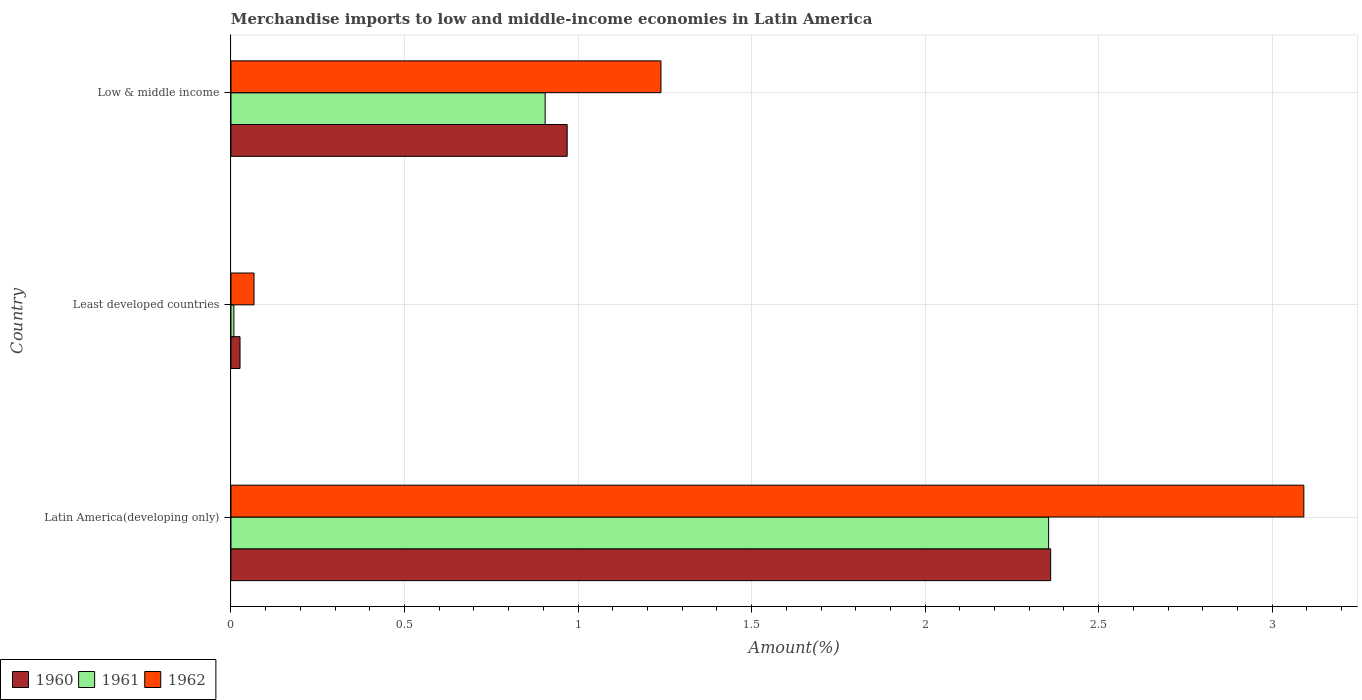How many different coloured bars are there?
Keep it short and to the point. 3. Are the number of bars on each tick of the Y-axis equal?
Ensure brevity in your answer.  Yes. How many bars are there on the 3rd tick from the top?
Your response must be concise. 3. How many bars are there on the 3rd tick from the bottom?
Make the answer very short. 3. What is the label of the 3rd group of bars from the top?
Offer a very short reply. Latin America(developing only). In how many cases, is the number of bars for a given country not equal to the number of legend labels?
Your response must be concise. 0. What is the percentage of amount earned from merchandise imports in 1960 in Low & middle income?
Offer a terse response. 0.97. Across all countries, what is the maximum percentage of amount earned from merchandise imports in 1960?
Ensure brevity in your answer.  2.36. Across all countries, what is the minimum percentage of amount earned from merchandise imports in 1961?
Your response must be concise. 0.01. In which country was the percentage of amount earned from merchandise imports in 1962 maximum?
Your answer should be very brief. Latin America(developing only). In which country was the percentage of amount earned from merchandise imports in 1962 minimum?
Your answer should be compact. Least developed countries. What is the total percentage of amount earned from merchandise imports in 1962 in the graph?
Provide a succinct answer. 4.4. What is the difference between the percentage of amount earned from merchandise imports in 1961 in Latin America(developing only) and that in Low & middle income?
Provide a short and direct response. 1.45. What is the difference between the percentage of amount earned from merchandise imports in 1960 in Latin America(developing only) and the percentage of amount earned from merchandise imports in 1961 in Least developed countries?
Ensure brevity in your answer.  2.35. What is the average percentage of amount earned from merchandise imports in 1960 per country?
Your answer should be compact. 1.12. What is the difference between the percentage of amount earned from merchandise imports in 1960 and percentage of amount earned from merchandise imports in 1961 in Least developed countries?
Provide a short and direct response. 0.02. What is the ratio of the percentage of amount earned from merchandise imports in 1962 in Latin America(developing only) to that in Least developed countries?
Your answer should be very brief. 46.58. What is the difference between the highest and the second highest percentage of amount earned from merchandise imports in 1961?
Your answer should be compact. 1.45. What is the difference between the highest and the lowest percentage of amount earned from merchandise imports in 1960?
Keep it short and to the point. 2.34. Is the sum of the percentage of amount earned from merchandise imports in 1961 in Latin America(developing only) and Low & middle income greater than the maximum percentage of amount earned from merchandise imports in 1960 across all countries?
Your response must be concise. Yes. Is it the case that in every country, the sum of the percentage of amount earned from merchandise imports in 1961 and percentage of amount earned from merchandise imports in 1960 is greater than the percentage of amount earned from merchandise imports in 1962?
Provide a short and direct response. No. How many bars are there?
Offer a terse response. 9. Are all the bars in the graph horizontal?
Your answer should be very brief. Yes. Are the values on the major ticks of X-axis written in scientific E-notation?
Provide a short and direct response. No. Does the graph contain any zero values?
Offer a terse response. No. Where does the legend appear in the graph?
Your response must be concise. Bottom left. What is the title of the graph?
Ensure brevity in your answer.  Merchandise imports to low and middle-income economies in Latin America. What is the label or title of the X-axis?
Make the answer very short. Amount(%). What is the Amount(%) in 1960 in Latin America(developing only)?
Offer a very short reply. 2.36. What is the Amount(%) in 1961 in Latin America(developing only)?
Offer a terse response. 2.36. What is the Amount(%) of 1962 in Latin America(developing only)?
Your response must be concise. 3.09. What is the Amount(%) in 1960 in Least developed countries?
Offer a terse response. 0.03. What is the Amount(%) of 1961 in Least developed countries?
Offer a terse response. 0.01. What is the Amount(%) in 1962 in Least developed countries?
Make the answer very short. 0.07. What is the Amount(%) of 1960 in Low & middle income?
Keep it short and to the point. 0.97. What is the Amount(%) of 1961 in Low & middle income?
Offer a very short reply. 0.91. What is the Amount(%) of 1962 in Low & middle income?
Make the answer very short. 1.24. Across all countries, what is the maximum Amount(%) in 1960?
Provide a succinct answer. 2.36. Across all countries, what is the maximum Amount(%) in 1961?
Offer a very short reply. 2.36. Across all countries, what is the maximum Amount(%) of 1962?
Offer a very short reply. 3.09. Across all countries, what is the minimum Amount(%) in 1960?
Your response must be concise. 0.03. Across all countries, what is the minimum Amount(%) of 1961?
Offer a very short reply. 0.01. Across all countries, what is the minimum Amount(%) of 1962?
Your answer should be compact. 0.07. What is the total Amount(%) in 1960 in the graph?
Keep it short and to the point. 3.36. What is the total Amount(%) in 1961 in the graph?
Your answer should be compact. 3.27. What is the total Amount(%) of 1962 in the graph?
Make the answer very short. 4.4. What is the difference between the Amount(%) in 1960 in Latin America(developing only) and that in Least developed countries?
Offer a very short reply. 2.34. What is the difference between the Amount(%) of 1961 in Latin America(developing only) and that in Least developed countries?
Your response must be concise. 2.35. What is the difference between the Amount(%) of 1962 in Latin America(developing only) and that in Least developed countries?
Ensure brevity in your answer.  3.02. What is the difference between the Amount(%) in 1960 in Latin America(developing only) and that in Low & middle income?
Offer a terse response. 1.39. What is the difference between the Amount(%) of 1961 in Latin America(developing only) and that in Low & middle income?
Your response must be concise. 1.45. What is the difference between the Amount(%) of 1962 in Latin America(developing only) and that in Low & middle income?
Ensure brevity in your answer.  1.85. What is the difference between the Amount(%) in 1960 in Least developed countries and that in Low & middle income?
Give a very brief answer. -0.94. What is the difference between the Amount(%) in 1961 in Least developed countries and that in Low & middle income?
Make the answer very short. -0.9. What is the difference between the Amount(%) in 1962 in Least developed countries and that in Low & middle income?
Offer a terse response. -1.17. What is the difference between the Amount(%) in 1960 in Latin America(developing only) and the Amount(%) in 1961 in Least developed countries?
Make the answer very short. 2.35. What is the difference between the Amount(%) of 1960 in Latin America(developing only) and the Amount(%) of 1962 in Least developed countries?
Your answer should be very brief. 2.3. What is the difference between the Amount(%) of 1961 in Latin America(developing only) and the Amount(%) of 1962 in Least developed countries?
Your answer should be very brief. 2.29. What is the difference between the Amount(%) of 1960 in Latin America(developing only) and the Amount(%) of 1961 in Low & middle income?
Keep it short and to the point. 1.46. What is the difference between the Amount(%) of 1960 in Latin America(developing only) and the Amount(%) of 1962 in Low & middle income?
Offer a very short reply. 1.12. What is the difference between the Amount(%) of 1961 in Latin America(developing only) and the Amount(%) of 1962 in Low & middle income?
Provide a short and direct response. 1.12. What is the difference between the Amount(%) of 1960 in Least developed countries and the Amount(%) of 1961 in Low & middle income?
Your response must be concise. -0.88. What is the difference between the Amount(%) in 1960 in Least developed countries and the Amount(%) in 1962 in Low & middle income?
Your answer should be compact. -1.21. What is the difference between the Amount(%) in 1961 in Least developed countries and the Amount(%) in 1962 in Low & middle income?
Provide a short and direct response. -1.23. What is the average Amount(%) in 1960 per country?
Provide a succinct answer. 1.12. What is the average Amount(%) of 1961 per country?
Your response must be concise. 1.09. What is the average Amount(%) in 1962 per country?
Make the answer very short. 1.47. What is the difference between the Amount(%) of 1960 and Amount(%) of 1961 in Latin America(developing only)?
Offer a very short reply. 0.01. What is the difference between the Amount(%) of 1960 and Amount(%) of 1962 in Latin America(developing only)?
Give a very brief answer. -0.73. What is the difference between the Amount(%) in 1961 and Amount(%) in 1962 in Latin America(developing only)?
Your response must be concise. -0.74. What is the difference between the Amount(%) in 1960 and Amount(%) in 1961 in Least developed countries?
Your answer should be very brief. 0.02. What is the difference between the Amount(%) of 1960 and Amount(%) of 1962 in Least developed countries?
Your answer should be compact. -0.04. What is the difference between the Amount(%) of 1961 and Amount(%) of 1962 in Least developed countries?
Your answer should be compact. -0.06. What is the difference between the Amount(%) of 1960 and Amount(%) of 1961 in Low & middle income?
Your answer should be very brief. 0.06. What is the difference between the Amount(%) in 1960 and Amount(%) in 1962 in Low & middle income?
Provide a succinct answer. -0.27. What is the difference between the Amount(%) in 1961 and Amount(%) in 1962 in Low & middle income?
Keep it short and to the point. -0.33. What is the ratio of the Amount(%) of 1960 in Latin America(developing only) to that in Least developed countries?
Your answer should be compact. 90.55. What is the ratio of the Amount(%) of 1961 in Latin America(developing only) to that in Least developed countries?
Offer a terse response. 282.62. What is the ratio of the Amount(%) in 1962 in Latin America(developing only) to that in Least developed countries?
Provide a short and direct response. 46.58. What is the ratio of the Amount(%) of 1960 in Latin America(developing only) to that in Low & middle income?
Offer a terse response. 2.44. What is the ratio of the Amount(%) of 1961 in Latin America(developing only) to that in Low & middle income?
Make the answer very short. 2.6. What is the ratio of the Amount(%) of 1962 in Latin America(developing only) to that in Low & middle income?
Provide a short and direct response. 2.5. What is the ratio of the Amount(%) of 1960 in Least developed countries to that in Low & middle income?
Keep it short and to the point. 0.03. What is the ratio of the Amount(%) in 1961 in Least developed countries to that in Low & middle income?
Make the answer very short. 0.01. What is the ratio of the Amount(%) of 1962 in Least developed countries to that in Low & middle income?
Ensure brevity in your answer.  0.05. What is the difference between the highest and the second highest Amount(%) of 1960?
Provide a short and direct response. 1.39. What is the difference between the highest and the second highest Amount(%) of 1961?
Your answer should be compact. 1.45. What is the difference between the highest and the second highest Amount(%) in 1962?
Offer a very short reply. 1.85. What is the difference between the highest and the lowest Amount(%) of 1960?
Your answer should be compact. 2.34. What is the difference between the highest and the lowest Amount(%) of 1961?
Your response must be concise. 2.35. What is the difference between the highest and the lowest Amount(%) in 1962?
Keep it short and to the point. 3.02. 